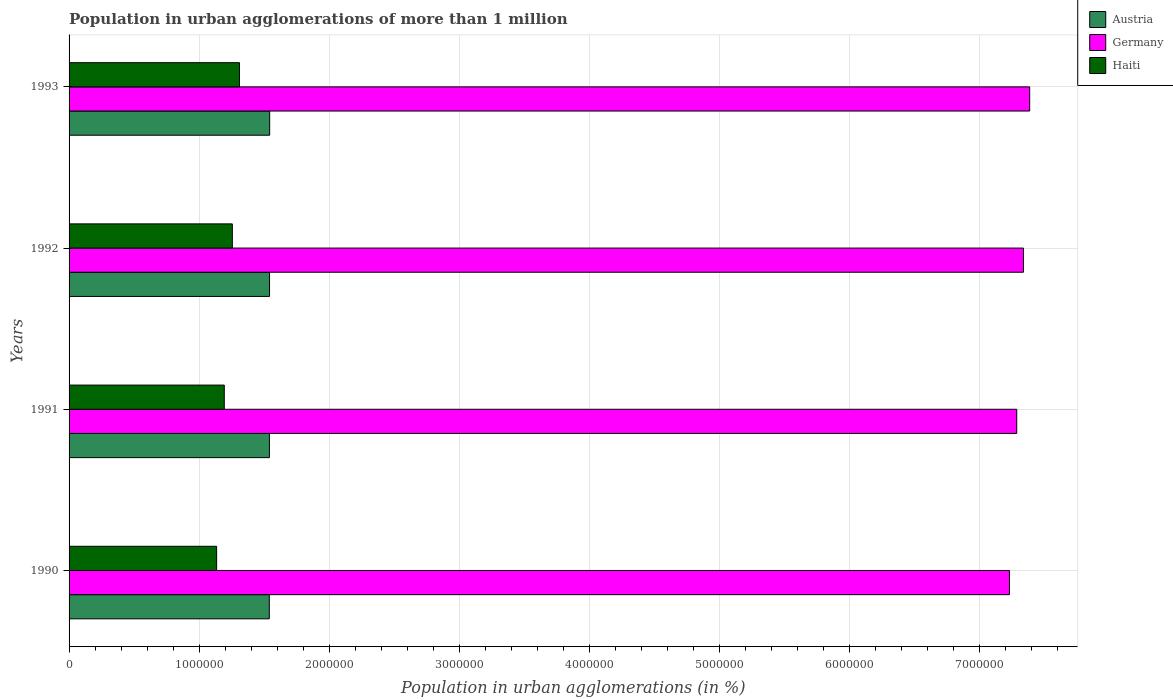Are the number of bars per tick equal to the number of legend labels?
Ensure brevity in your answer.  Yes. Are the number of bars on each tick of the Y-axis equal?
Your answer should be very brief. Yes. How many bars are there on the 4th tick from the top?
Ensure brevity in your answer.  3. How many bars are there on the 1st tick from the bottom?
Ensure brevity in your answer.  3. In how many cases, is the number of bars for a given year not equal to the number of legend labels?
Give a very brief answer. 0. What is the population in urban agglomerations in Germany in 1991?
Make the answer very short. 7.28e+06. Across all years, what is the maximum population in urban agglomerations in Austria?
Your answer should be very brief. 1.54e+06. Across all years, what is the minimum population in urban agglomerations in Austria?
Ensure brevity in your answer.  1.54e+06. In which year was the population in urban agglomerations in Germany minimum?
Provide a succinct answer. 1990. What is the total population in urban agglomerations in Haiti in the graph?
Your answer should be very brief. 4.89e+06. What is the difference between the population in urban agglomerations in Germany in 1990 and that in 1993?
Give a very brief answer. -1.56e+05. What is the difference between the population in urban agglomerations in Haiti in 1992 and the population in urban agglomerations in Austria in 1991?
Offer a very short reply. -2.85e+05. What is the average population in urban agglomerations in Haiti per year?
Ensure brevity in your answer.  1.22e+06. In the year 1993, what is the difference between the population in urban agglomerations in Austria and population in urban agglomerations in Haiti?
Your answer should be compact. 2.32e+05. What is the ratio of the population in urban agglomerations in Germany in 1991 to that in 1993?
Your response must be concise. 0.99. Is the population in urban agglomerations in Austria in 1990 less than that in 1992?
Offer a terse response. Yes. What is the difference between the highest and the second highest population in urban agglomerations in Austria?
Ensure brevity in your answer.  1024. What is the difference between the highest and the lowest population in urban agglomerations in Haiti?
Your answer should be compact. 1.76e+05. In how many years, is the population in urban agglomerations in Haiti greater than the average population in urban agglomerations in Haiti taken over all years?
Provide a succinct answer. 2. What does the 1st bar from the top in 1993 represents?
Make the answer very short. Haiti. What does the 3rd bar from the bottom in 1991 represents?
Your response must be concise. Haiti. How many bars are there?
Offer a terse response. 12. How many years are there in the graph?
Your response must be concise. 4. Does the graph contain grids?
Your response must be concise. Yes. How are the legend labels stacked?
Make the answer very short. Vertical. What is the title of the graph?
Ensure brevity in your answer.  Population in urban agglomerations of more than 1 million. Does "Cayman Islands" appear as one of the legend labels in the graph?
Make the answer very short. No. What is the label or title of the X-axis?
Offer a very short reply. Population in urban agglomerations (in %). What is the Population in urban agglomerations (in %) in Austria in 1990?
Make the answer very short. 1.54e+06. What is the Population in urban agglomerations (in %) in Germany in 1990?
Give a very brief answer. 7.23e+06. What is the Population in urban agglomerations (in %) of Haiti in 1990?
Your answer should be compact. 1.13e+06. What is the Population in urban agglomerations (in %) of Austria in 1991?
Offer a very short reply. 1.54e+06. What is the Population in urban agglomerations (in %) in Germany in 1991?
Give a very brief answer. 7.28e+06. What is the Population in urban agglomerations (in %) of Haiti in 1991?
Provide a succinct answer. 1.19e+06. What is the Population in urban agglomerations (in %) in Austria in 1992?
Make the answer very short. 1.54e+06. What is the Population in urban agglomerations (in %) of Germany in 1992?
Make the answer very short. 7.34e+06. What is the Population in urban agglomerations (in %) in Haiti in 1992?
Make the answer very short. 1.26e+06. What is the Population in urban agglomerations (in %) in Austria in 1993?
Offer a very short reply. 1.54e+06. What is the Population in urban agglomerations (in %) in Germany in 1993?
Keep it short and to the point. 7.38e+06. What is the Population in urban agglomerations (in %) in Haiti in 1993?
Offer a terse response. 1.31e+06. Across all years, what is the maximum Population in urban agglomerations (in %) of Austria?
Provide a succinct answer. 1.54e+06. Across all years, what is the maximum Population in urban agglomerations (in %) of Germany?
Provide a succinct answer. 7.38e+06. Across all years, what is the maximum Population in urban agglomerations (in %) in Haiti?
Provide a short and direct response. 1.31e+06. Across all years, what is the minimum Population in urban agglomerations (in %) in Austria?
Offer a very short reply. 1.54e+06. Across all years, what is the minimum Population in urban agglomerations (in %) of Germany?
Keep it short and to the point. 7.23e+06. Across all years, what is the minimum Population in urban agglomerations (in %) of Haiti?
Provide a succinct answer. 1.13e+06. What is the total Population in urban agglomerations (in %) of Austria in the graph?
Your answer should be very brief. 6.16e+06. What is the total Population in urban agglomerations (in %) in Germany in the graph?
Provide a short and direct response. 2.92e+07. What is the total Population in urban agglomerations (in %) in Haiti in the graph?
Make the answer very short. 4.89e+06. What is the difference between the Population in urban agglomerations (in %) in Austria in 1990 and that in 1991?
Offer a terse response. -874. What is the difference between the Population in urban agglomerations (in %) of Germany in 1990 and that in 1991?
Offer a very short reply. -5.60e+04. What is the difference between the Population in urban agglomerations (in %) in Haiti in 1990 and that in 1991?
Give a very brief answer. -5.88e+04. What is the difference between the Population in urban agglomerations (in %) in Austria in 1990 and that in 1992?
Your response must be concise. -1900. What is the difference between the Population in urban agglomerations (in %) in Germany in 1990 and that in 1992?
Keep it short and to the point. -1.08e+05. What is the difference between the Population in urban agglomerations (in %) in Haiti in 1990 and that in 1992?
Keep it short and to the point. -1.21e+05. What is the difference between the Population in urban agglomerations (in %) of Austria in 1990 and that in 1993?
Keep it short and to the point. -2924. What is the difference between the Population in urban agglomerations (in %) in Germany in 1990 and that in 1993?
Your answer should be very brief. -1.56e+05. What is the difference between the Population in urban agglomerations (in %) in Haiti in 1990 and that in 1993?
Your response must be concise. -1.76e+05. What is the difference between the Population in urban agglomerations (in %) in Austria in 1991 and that in 1992?
Your answer should be very brief. -1026. What is the difference between the Population in urban agglomerations (in %) in Germany in 1991 and that in 1992?
Ensure brevity in your answer.  -5.15e+04. What is the difference between the Population in urban agglomerations (in %) in Haiti in 1991 and that in 1992?
Make the answer very short. -6.20e+04. What is the difference between the Population in urban agglomerations (in %) of Austria in 1991 and that in 1993?
Give a very brief answer. -2050. What is the difference between the Population in urban agglomerations (in %) of Germany in 1991 and that in 1993?
Your answer should be very brief. -9.95e+04. What is the difference between the Population in urban agglomerations (in %) of Haiti in 1991 and that in 1993?
Offer a very short reply. -1.17e+05. What is the difference between the Population in urban agglomerations (in %) in Austria in 1992 and that in 1993?
Your response must be concise. -1024. What is the difference between the Population in urban agglomerations (in %) of Germany in 1992 and that in 1993?
Ensure brevity in your answer.  -4.80e+04. What is the difference between the Population in urban agglomerations (in %) in Haiti in 1992 and that in 1993?
Give a very brief answer. -5.49e+04. What is the difference between the Population in urban agglomerations (in %) in Austria in 1990 and the Population in urban agglomerations (in %) in Germany in 1991?
Your answer should be compact. -5.75e+06. What is the difference between the Population in urban agglomerations (in %) of Austria in 1990 and the Population in urban agglomerations (in %) of Haiti in 1991?
Give a very brief answer. 3.46e+05. What is the difference between the Population in urban agglomerations (in %) of Germany in 1990 and the Population in urban agglomerations (in %) of Haiti in 1991?
Offer a very short reply. 6.04e+06. What is the difference between the Population in urban agglomerations (in %) in Austria in 1990 and the Population in urban agglomerations (in %) in Germany in 1992?
Provide a short and direct response. -5.80e+06. What is the difference between the Population in urban agglomerations (in %) in Austria in 1990 and the Population in urban agglomerations (in %) in Haiti in 1992?
Your answer should be compact. 2.84e+05. What is the difference between the Population in urban agglomerations (in %) in Germany in 1990 and the Population in urban agglomerations (in %) in Haiti in 1992?
Give a very brief answer. 5.97e+06. What is the difference between the Population in urban agglomerations (in %) in Austria in 1990 and the Population in urban agglomerations (in %) in Germany in 1993?
Offer a terse response. -5.84e+06. What is the difference between the Population in urban agglomerations (in %) of Austria in 1990 and the Population in urban agglomerations (in %) of Haiti in 1993?
Your answer should be very brief. 2.29e+05. What is the difference between the Population in urban agglomerations (in %) in Germany in 1990 and the Population in urban agglomerations (in %) in Haiti in 1993?
Provide a short and direct response. 5.92e+06. What is the difference between the Population in urban agglomerations (in %) of Austria in 1991 and the Population in urban agglomerations (in %) of Germany in 1992?
Keep it short and to the point. -5.80e+06. What is the difference between the Population in urban agglomerations (in %) of Austria in 1991 and the Population in urban agglomerations (in %) of Haiti in 1992?
Offer a terse response. 2.85e+05. What is the difference between the Population in urban agglomerations (in %) in Germany in 1991 and the Population in urban agglomerations (in %) in Haiti in 1992?
Ensure brevity in your answer.  6.03e+06. What is the difference between the Population in urban agglomerations (in %) in Austria in 1991 and the Population in urban agglomerations (in %) in Germany in 1993?
Provide a short and direct response. -5.84e+06. What is the difference between the Population in urban agglomerations (in %) of Austria in 1991 and the Population in urban agglomerations (in %) of Haiti in 1993?
Provide a succinct answer. 2.30e+05. What is the difference between the Population in urban agglomerations (in %) in Germany in 1991 and the Population in urban agglomerations (in %) in Haiti in 1993?
Offer a very short reply. 5.97e+06. What is the difference between the Population in urban agglomerations (in %) in Austria in 1992 and the Population in urban agglomerations (in %) in Germany in 1993?
Offer a terse response. -5.84e+06. What is the difference between the Population in urban agglomerations (in %) in Austria in 1992 and the Population in urban agglomerations (in %) in Haiti in 1993?
Offer a very short reply. 2.31e+05. What is the difference between the Population in urban agglomerations (in %) in Germany in 1992 and the Population in urban agglomerations (in %) in Haiti in 1993?
Make the answer very short. 6.03e+06. What is the average Population in urban agglomerations (in %) of Austria per year?
Offer a terse response. 1.54e+06. What is the average Population in urban agglomerations (in %) in Germany per year?
Keep it short and to the point. 7.31e+06. What is the average Population in urban agglomerations (in %) in Haiti per year?
Give a very brief answer. 1.22e+06. In the year 1990, what is the difference between the Population in urban agglomerations (in %) of Austria and Population in urban agglomerations (in %) of Germany?
Make the answer very short. -5.69e+06. In the year 1990, what is the difference between the Population in urban agglomerations (in %) of Austria and Population in urban agglomerations (in %) of Haiti?
Your answer should be compact. 4.05e+05. In the year 1990, what is the difference between the Population in urban agglomerations (in %) of Germany and Population in urban agglomerations (in %) of Haiti?
Offer a terse response. 6.09e+06. In the year 1991, what is the difference between the Population in urban agglomerations (in %) of Austria and Population in urban agglomerations (in %) of Germany?
Provide a succinct answer. -5.74e+06. In the year 1991, what is the difference between the Population in urban agglomerations (in %) of Austria and Population in urban agglomerations (in %) of Haiti?
Your answer should be very brief. 3.47e+05. In the year 1991, what is the difference between the Population in urban agglomerations (in %) of Germany and Population in urban agglomerations (in %) of Haiti?
Your answer should be compact. 6.09e+06. In the year 1992, what is the difference between the Population in urban agglomerations (in %) of Austria and Population in urban agglomerations (in %) of Germany?
Your response must be concise. -5.80e+06. In the year 1992, what is the difference between the Population in urban agglomerations (in %) in Austria and Population in urban agglomerations (in %) in Haiti?
Your response must be concise. 2.86e+05. In the year 1992, what is the difference between the Population in urban agglomerations (in %) of Germany and Population in urban agglomerations (in %) of Haiti?
Provide a succinct answer. 6.08e+06. In the year 1993, what is the difference between the Population in urban agglomerations (in %) in Austria and Population in urban agglomerations (in %) in Germany?
Give a very brief answer. -5.84e+06. In the year 1993, what is the difference between the Population in urban agglomerations (in %) in Austria and Population in urban agglomerations (in %) in Haiti?
Offer a very short reply. 2.32e+05. In the year 1993, what is the difference between the Population in urban agglomerations (in %) in Germany and Population in urban agglomerations (in %) in Haiti?
Provide a succinct answer. 6.07e+06. What is the ratio of the Population in urban agglomerations (in %) of Haiti in 1990 to that in 1991?
Your answer should be very brief. 0.95. What is the ratio of the Population in urban agglomerations (in %) in Austria in 1990 to that in 1992?
Keep it short and to the point. 1. What is the ratio of the Population in urban agglomerations (in %) of Haiti in 1990 to that in 1992?
Your response must be concise. 0.9. What is the ratio of the Population in urban agglomerations (in %) of Austria in 1990 to that in 1993?
Keep it short and to the point. 1. What is the ratio of the Population in urban agglomerations (in %) in Germany in 1990 to that in 1993?
Your response must be concise. 0.98. What is the ratio of the Population in urban agglomerations (in %) of Haiti in 1990 to that in 1993?
Make the answer very short. 0.87. What is the ratio of the Population in urban agglomerations (in %) in Austria in 1991 to that in 1992?
Provide a succinct answer. 1. What is the ratio of the Population in urban agglomerations (in %) in Haiti in 1991 to that in 1992?
Offer a terse response. 0.95. What is the ratio of the Population in urban agglomerations (in %) in Germany in 1991 to that in 1993?
Provide a short and direct response. 0.99. What is the ratio of the Population in urban agglomerations (in %) of Haiti in 1991 to that in 1993?
Your answer should be very brief. 0.91. What is the ratio of the Population in urban agglomerations (in %) of Germany in 1992 to that in 1993?
Give a very brief answer. 0.99. What is the ratio of the Population in urban agglomerations (in %) in Haiti in 1992 to that in 1993?
Keep it short and to the point. 0.96. What is the difference between the highest and the second highest Population in urban agglomerations (in %) of Austria?
Give a very brief answer. 1024. What is the difference between the highest and the second highest Population in urban agglomerations (in %) in Germany?
Give a very brief answer. 4.80e+04. What is the difference between the highest and the second highest Population in urban agglomerations (in %) of Haiti?
Give a very brief answer. 5.49e+04. What is the difference between the highest and the lowest Population in urban agglomerations (in %) of Austria?
Make the answer very short. 2924. What is the difference between the highest and the lowest Population in urban agglomerations (in %) of Germany?
Offer a terse response. 1.56e+05. What is the difference between the highest and the lowest Population in urban agglomerations (in %) of Haiti?
Your answer should be compact. 1.76e+05. 